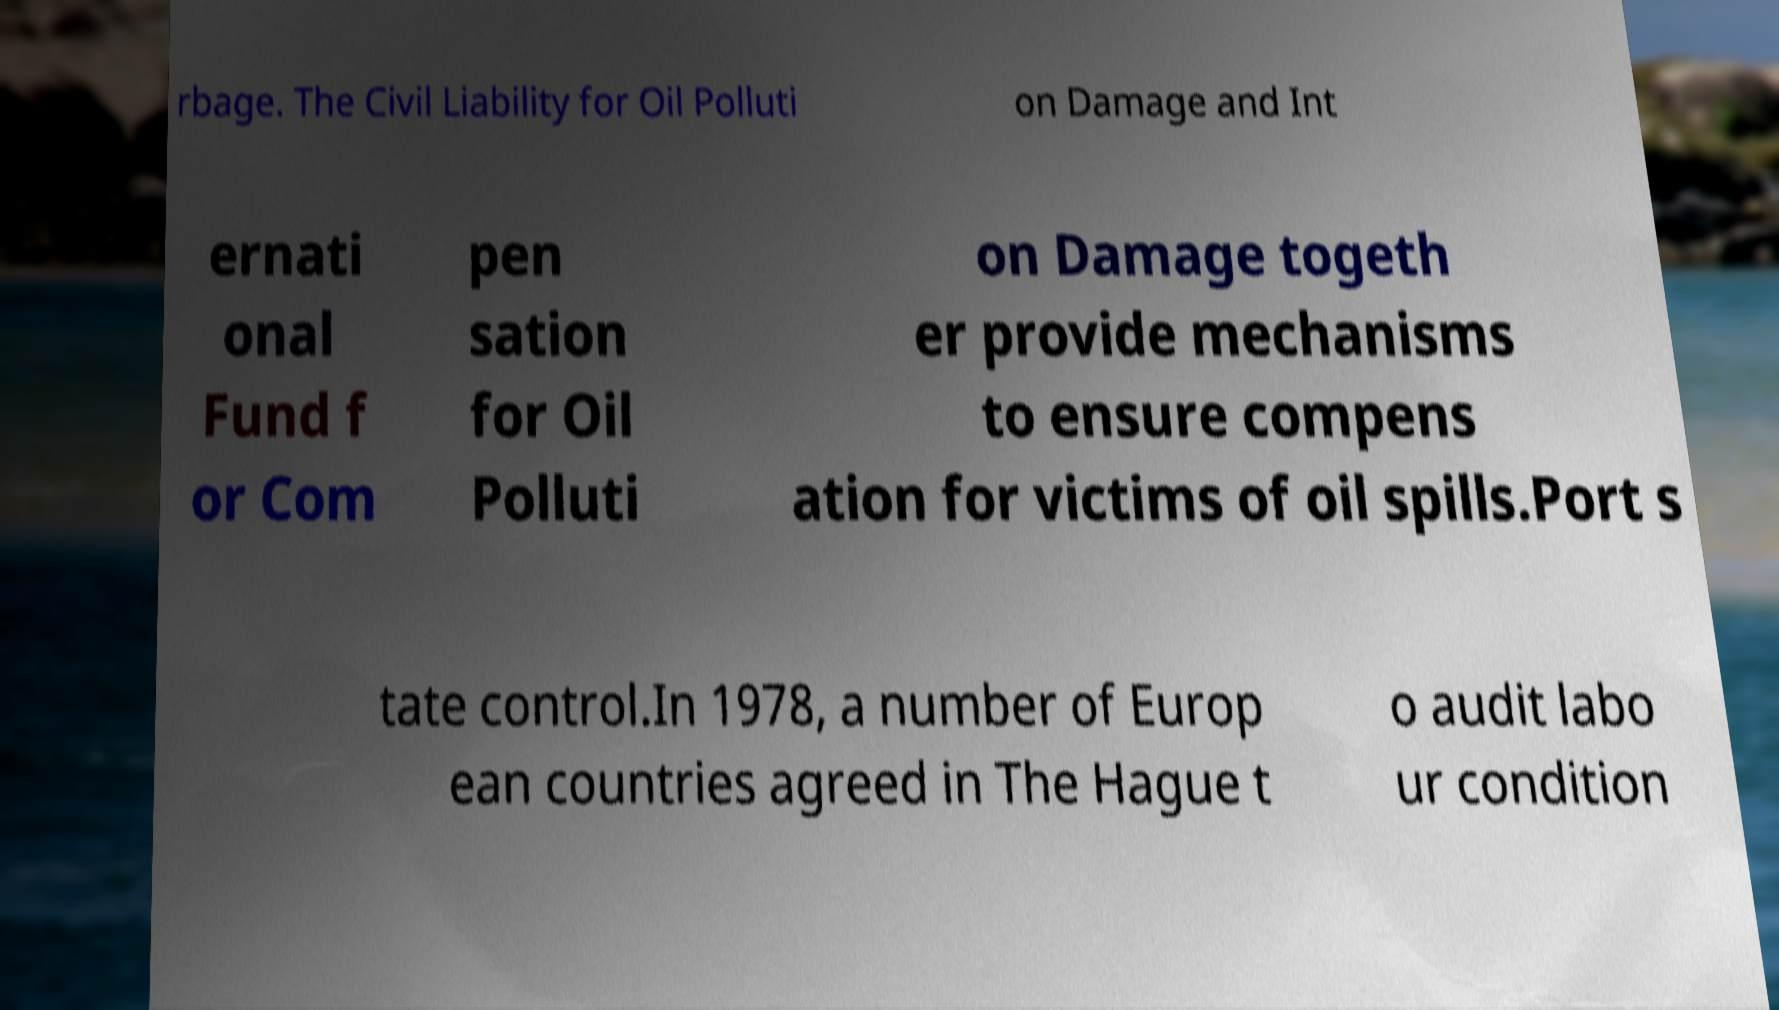Can you accurately transcribe the text from the provided image for me? rbage. The Civil Liability for Oil Polluti on Damage and Int ernati onal Fund f or Com pen sation for Oil Polluti on Damage togeth er provide mechanisms to ensure compens ation for victims of oil spills.Port s tate control.In 1978, a number of Europ ean countries agreed in The Hague t o audit labo ur condition 